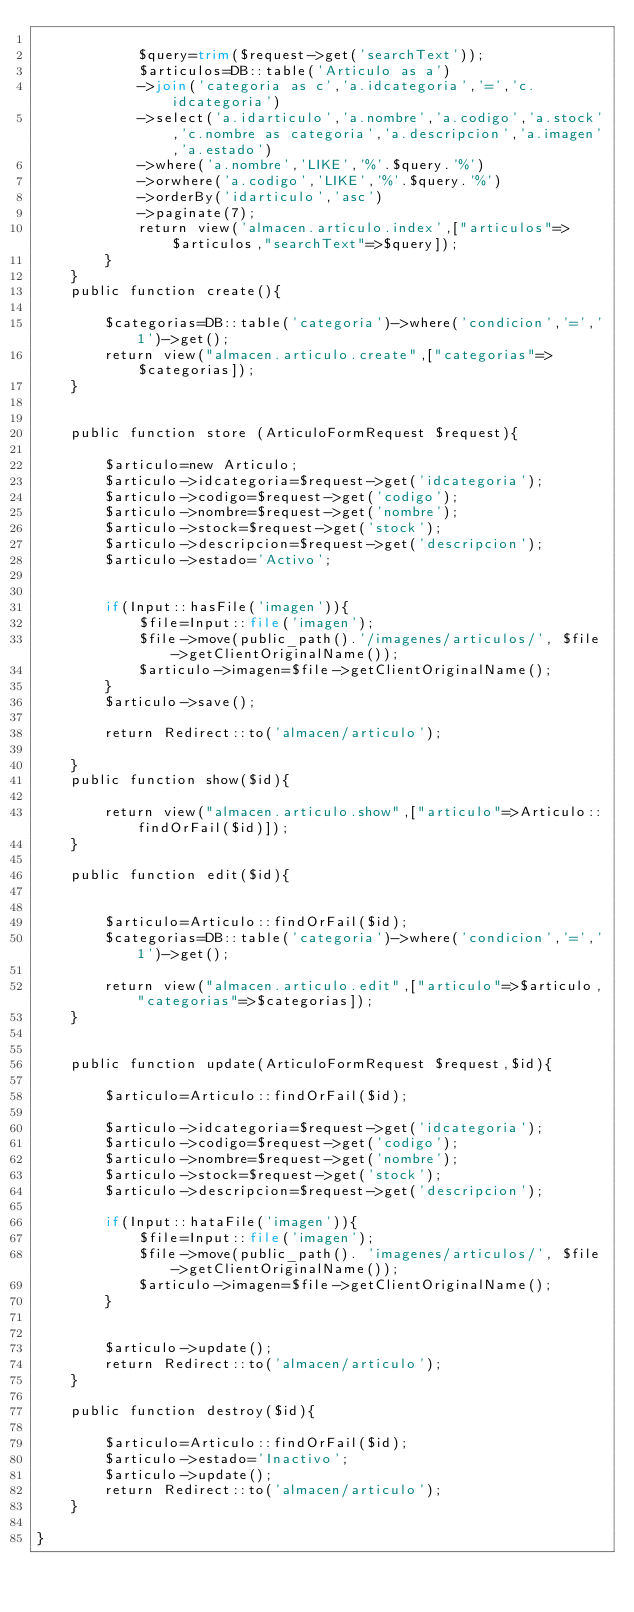<code> <loc_0><loc_0><loc_500><loc_500><_PHP_>
            $query=trim($request->get('searchText'));
            $articulos=DB::table('Articulo as a')
            ->join('categoria as c','a.idcategoria','=','c.idcategoria')
            ->select('a.idarticulo','a.nombre','a.codigo','a.stock','c.nombre as categoria','a.descripcion','a.imagen','a.estado')
            ->where('a.nombre','LIKE','%'.$query.'%')
            ->orwhere('a.codigo','LIKE','%'.$query.'%')
            ->orderBy('idarticulo','asc')
            ->paginate(7);
            return view('almacen.articulo.index',["articulos"=>$articulos,"searchText"=>$query]);
        }
    }
    public function create(){

        $categorias=DB::table('categoria')->where('condicion','=','1')->get();
        return view("almacen.articulo.create",["categorias"=>$categorias]);
    }


    public function store (ArticuloFormRequest $request){

        $articulo=new Articulo;
        $articulo->idcategoria=$request->get('idcategoria');
        $articulo->codigo=$request->get('codigo');
        $articulo->nombre=$request->get('nombre');
        $articulo->stock=$request->get('stock');
        $articulo->descripcion=$request->get('descripcion');
        $articulo->estado='Activo';


        if(Input::hasFile('imagen')){
            $file=Input::file('imagen');
            $file->move(public_path().'/imagenes/articulos/', $file->getClientOriginalName());
            $articulo->imagen=$file->getClientOriginalName();     
        }
        $articulo->save();
   
        return Redirect::to('almacen/articulo');

    }
    public function show($id){

        return view("almacen.articulo.show",["articulo"=>Articulo::findOrFail($id)]);
    }

    public function edit($id){


        $articulo=Articulo::findOrFail($id);
        $categorias=DB::table('categoria')->where('condicion','=','1')->get();

        return view("almacen.articulo.edit",["articulo"=>$articulo,"categorias"=>$categorias]);
    }


    public function update(ArticuloFormRequest $request,$id){

        $articulo=Articulo::findOrFail($id);

        $articulo->idcategoria=$request->get('idcategoria');
        $articulo->codigo=$request->get('codigo');
        $articulo->nombre=$request->get('nombre');
        $articulo->stock=$request->get('stock');
        $articulo->descripcion=$request->get('descripcion');
       
        if(Input::hataFile('imagen')){
            $file=Input::file('imagen');
            $file->move(public_path(). 'imagenes/articulos/', $file->getClientOriginalName());
            $articulo->imagen=$file->getClientOriginalName();     
        }

      
        $articulo->update();
        return Redirect::to('almacen/articulo');
    }

    public function destroy($id){

        $articulo=Articulo::findOrFail($id);
        $articulo->estado='Inactivo';
        $articulo->update();
        return Redirect::to('almacen/articulo');
    }

}
</code> 